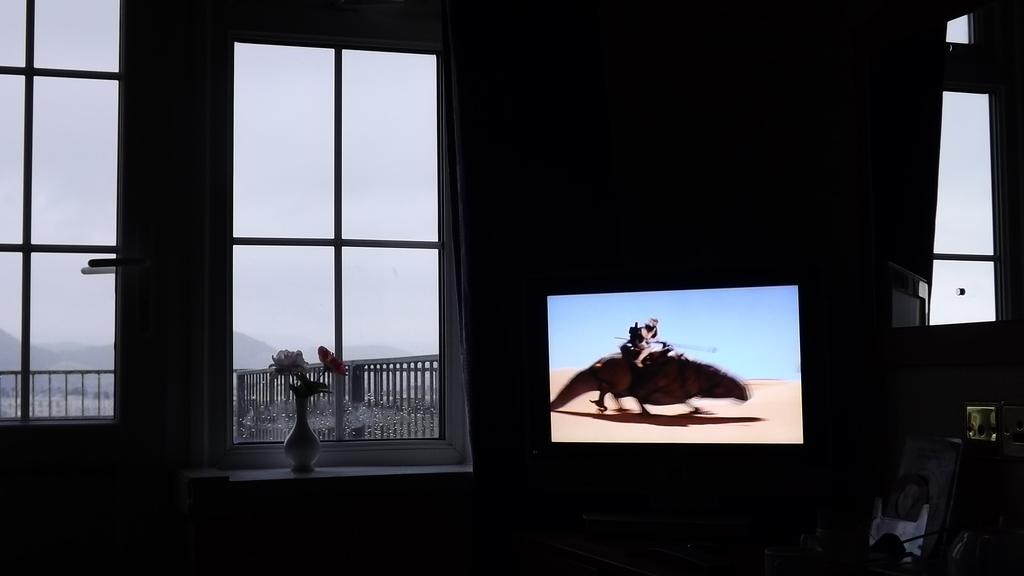What type of structure is present in the image? There is a glass window in the image. What can be seen on the window sill? There is a flower vase in the image. What electronic device is visible in the image? There is a television in the image. What is being displayed on the television? There is a picture on the television. What type of window treatment is present in the image? There is a curtain in the image. What can be seen outside the window? The sky is visible in the image. Where is the frame of the cemetery located in the image? There is no cemetery or frame present in the image. Can you describe the mom be seen in the image? There is no person named mom or any person visible in the image. 